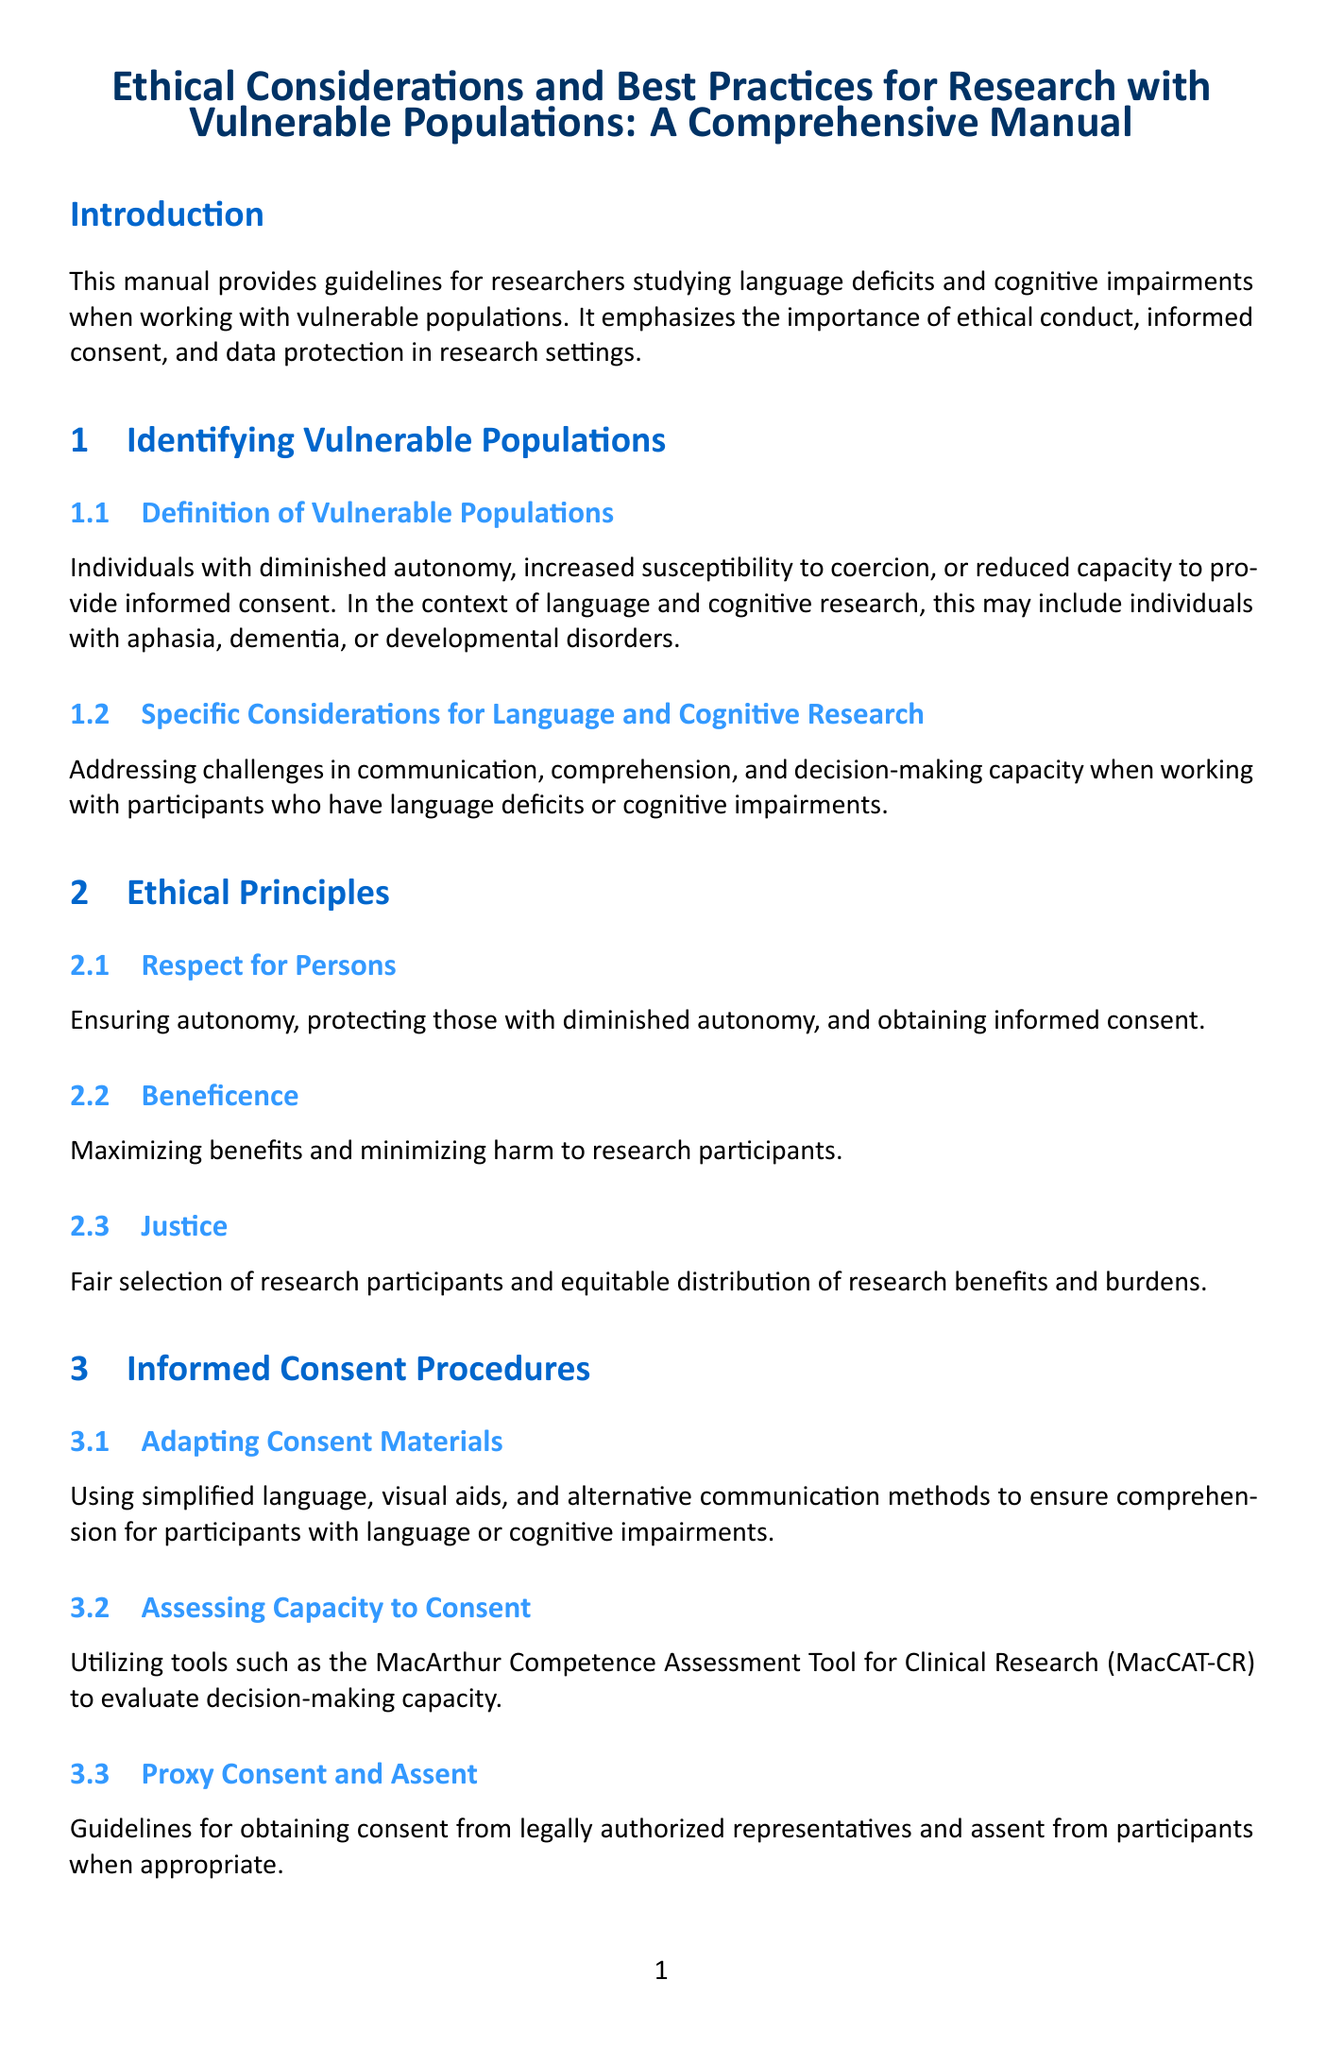What is the title of the manual? The title can be found at the center of the document and gives a summary of its content.
Answer: Ethical Considerations and Best Practices for Research with Vulnerable Populations: A Comprehensive Manual Who are considered vulnerable populations? This information is provided in the section that defines vulnerable populations, highlighting the characteristics that categorize them.
Answer: Individuals with diminished autonomy What does the principle of beneficence refer to? This ethical principle is described in the document and focuses on the overall aim of research regarding participant welfare.
Answer: Maximizing benefits and minimizing harm What tool is recommended for assessing capacity to consent? The section on consent procedures specifies a tool that researchers can use to evaluate decision-making capacity.
Answer: MacArthur Competence Assessment Tool for Clinical Research Name a method for ensuring data confidentiality. This information is outlined in the data protection protocols section, detailing measures to protect participant identities.
Answer: Secure data storage systems What strategies are suggested for minimizing participant stress during assessments? This guidance is found in a subsection addressing considerations specific to language and cognitive assessments.
Answer: Frequent breaks and flexible scheduling What is the purpose of Institutional Review Board (IRB) submission? This requirement is explained under the section about ethical review, detailing the importance for researchers.
Answer: Preparing comprehensive protocols for IRB review How should research findings be responsibly reported? This guideline is part of the dissemination section, emphasizing ethical practices when sharing results publicly.
Answer: Maintaining participant confidentiality What does the manual emphasize about ongoing ethical considerations? The conclusion section highlights the importance of this aspect in the context of research with vulnerable groups.
Answer: Staying informed about evolving best practices 